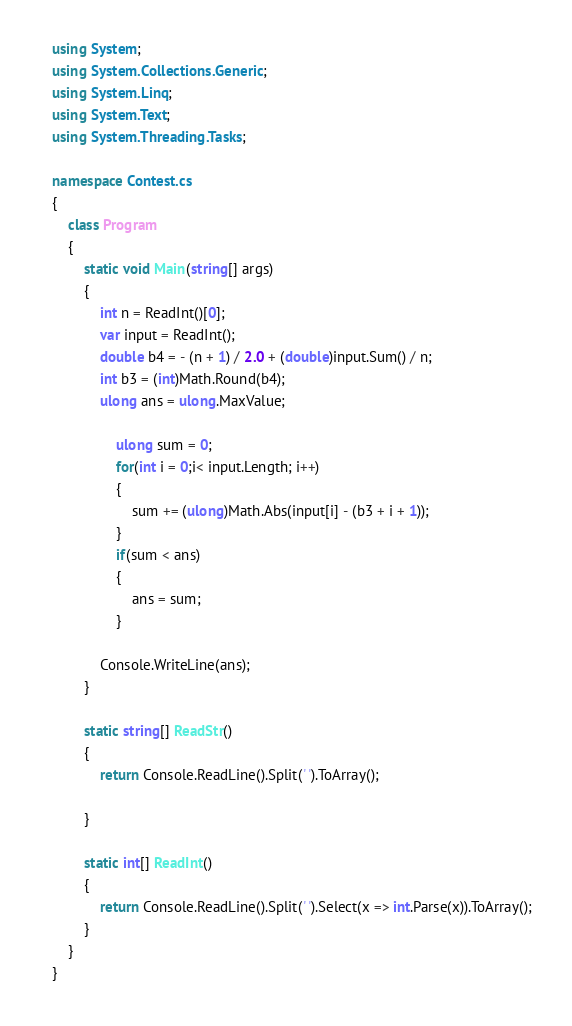Convert code to text. <code><loc_0><loc_0><loc_500><loc_500><_C#_>using System;
using System.Collections.Generic;
using System.Linq;
using System.Text;
using System.Threading.Tasks;

namespace Contest.cs
{
	class Program
	{
		static void Main(string[] args)
		{
			int n = ReadInt()[0];
			var input = ReadInt();
			double b4 = - (n + 1) / 2.0 + (double)input.Sum() / n;
			int b3 = (int)Math.Round(b4);
			ulong ans = ulong.MaxValue;
			
				ulong sum = 0;
				for(int i = 0;i< input.Length; i++)
				{
					sum += (ulong)Math.Abs(input[i] - (b3 + i + 1));
				}
				if(sum < ans)
				{
					ans = sum;
				}
			
			Console.WriteLine(ans);
		}

		static string[] ReadStr()
		{
			return Console.ReadLine().Split(' ').ToArray();

		}

		static int[] ReadInt()
		{
			return Console.ReadLine().Split(' ').Select(x => int.Parse(x)).ToArray();
		}
	}
}</code> 